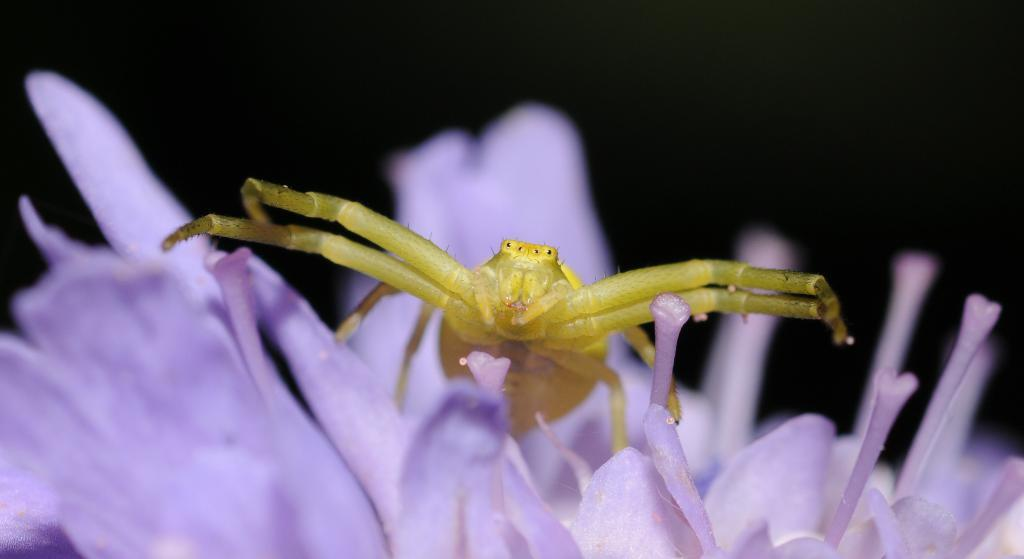What type of insect is in the image? There is a green grasshopper in the image. What is the grasshopper sitting on? The grasshopper is sitting on a blue flower. What color is the background in the image? The background in the image is black. What type of dress is the grasshopper wearing in the image? There is no dress present in the image, as grasshoppers do not wear clothing. 